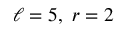Convert formula to latex. <formula><loc_0><loc_0><loc_500><loc_500>\ell = 5 , \ r = 2</formula> 